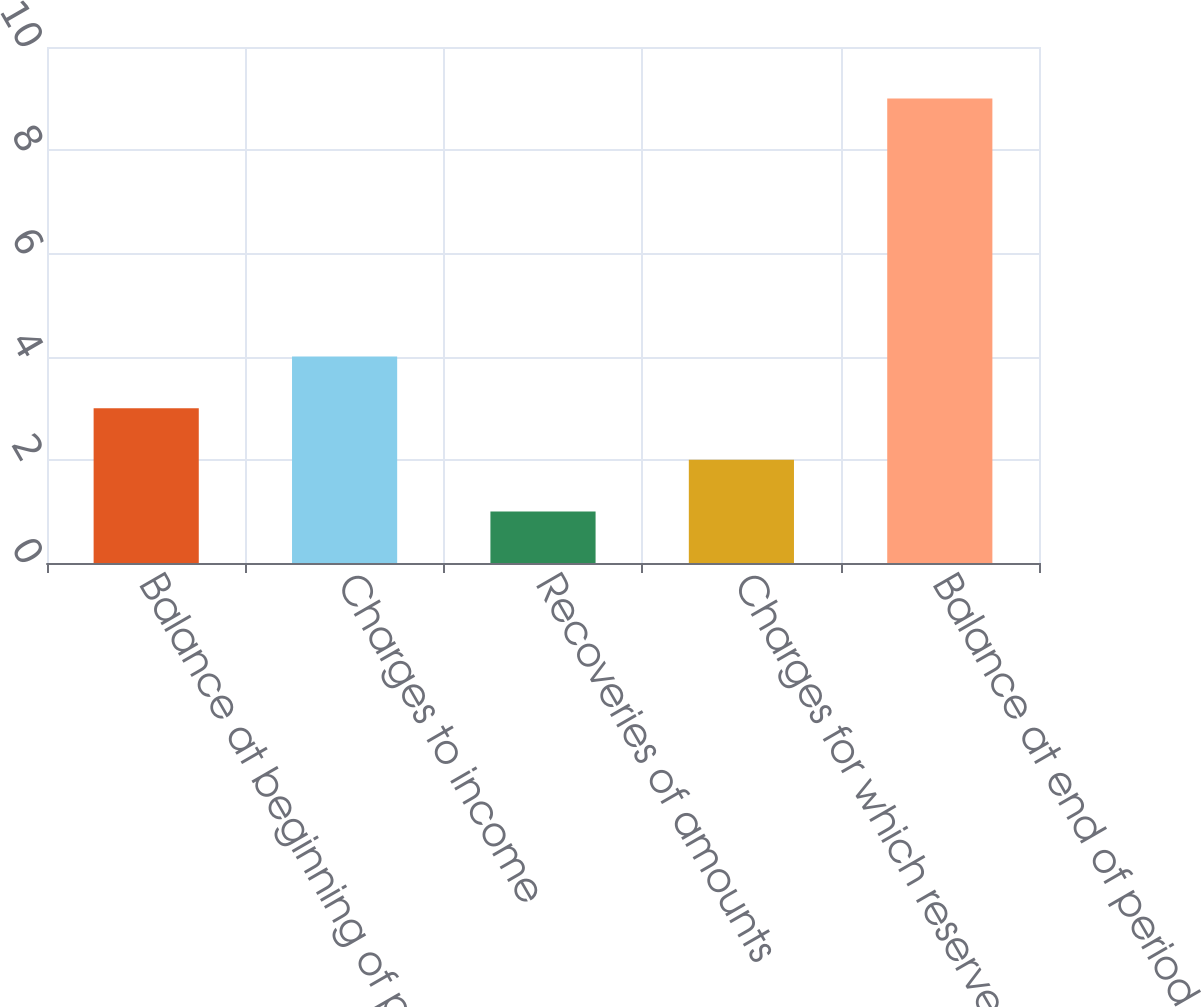Convert chart. <chart><loc_0><loc_0><loc_500><loc_500><bar_chart><fcel>Balance at beginning of period<fcel>Charges to income<fcel>Recoveries of amounts<fcel>Charges for which reserves<fcel>Balance at end of period<nl><fcel>3<fcel>4<fcel>1<fcel>2<fcel>9<nl></chart> 